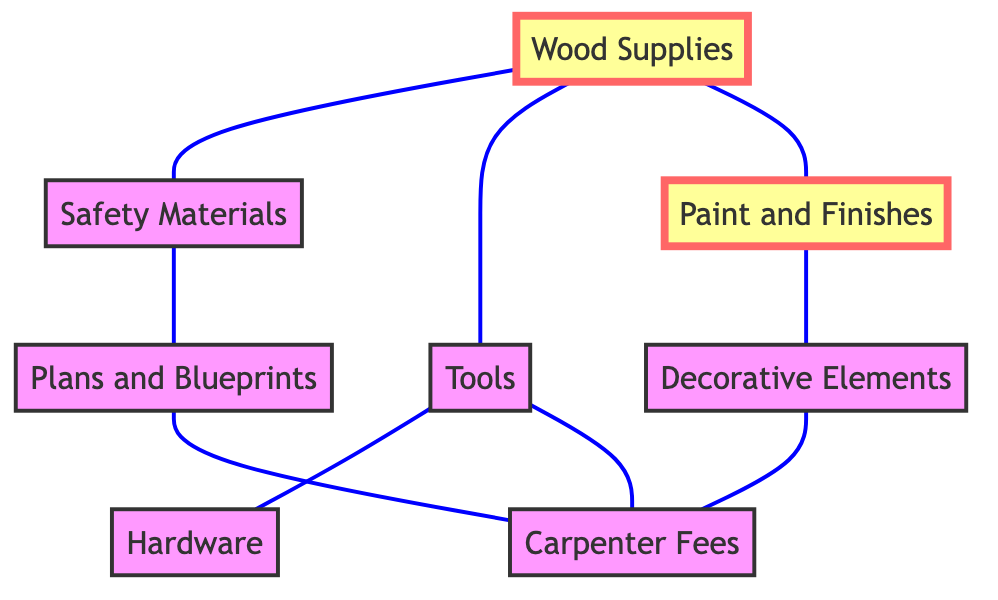What's the total number of nodes in the diagram? The diagram lists eight distinct nodes: Wood Supplies, Safety Materials, Tools, Paint and Finishes, Hardware, Decorative Elements, Carpenter Fees, and Plans and Blueprints.
Answer: Eight How many total links (connections) exist between the nodes? By counting the connections in the links section of the diagram, we find eight links connecting different pairs of nodes.
Answer: Eight Which node connects to both Tools and Hardware? The Tools node connects to the Hardware node as per the links listed, meaning only the Tools node has this connection.
Answer: Tools Is there a connection between Wood Supplies and Plans and Blueprints? The diagram shows links, and there is no direct connection between the Wood Supplies and Plans and Blueprints nodes.
Answer: No What is the role of Wood Supplies in the diagram? Wood Supplies serves as a fundamental node connecting to Safety Materials, Tools, and Paint and Finishes, indicating it is crucial for the nursery furniture project.
Answer: Fundamental Which two nodes are ultimately linked through Carpenter Fees? The Carpenter Fees node is connected indirectly via Tools, Safety Materials, and Plans and Blueprints to different nodes, but initially connects to the Tools and Decorative Elements.
Answer: Tools and Decorative Elements Name a node that connects to Decorative Elements. The Decorative Elements node is connected through a link with Paint and Finishes based on the connections defined in the diagram.
Answer: Paint and Finishes Identify a safety-related component in the diagram. Safety Materials is explicitly identified in the diagram as a component related to safety for the nursery furniture.
Answer: Safety Materials What node serves as a basis for many connections in the graph? The Wood Supplies node has multiple connections to Safety Materials, Tools, and Paint and Finishes, making it a central node in the project.
Answer: Wood Supplies How are Safety Materials and Plans and Blueprints related? Safety Materials directly connects to Plans and Blueprints according to the diagram, indicating a straightforward relationship between them.
Answer: Directly connected 